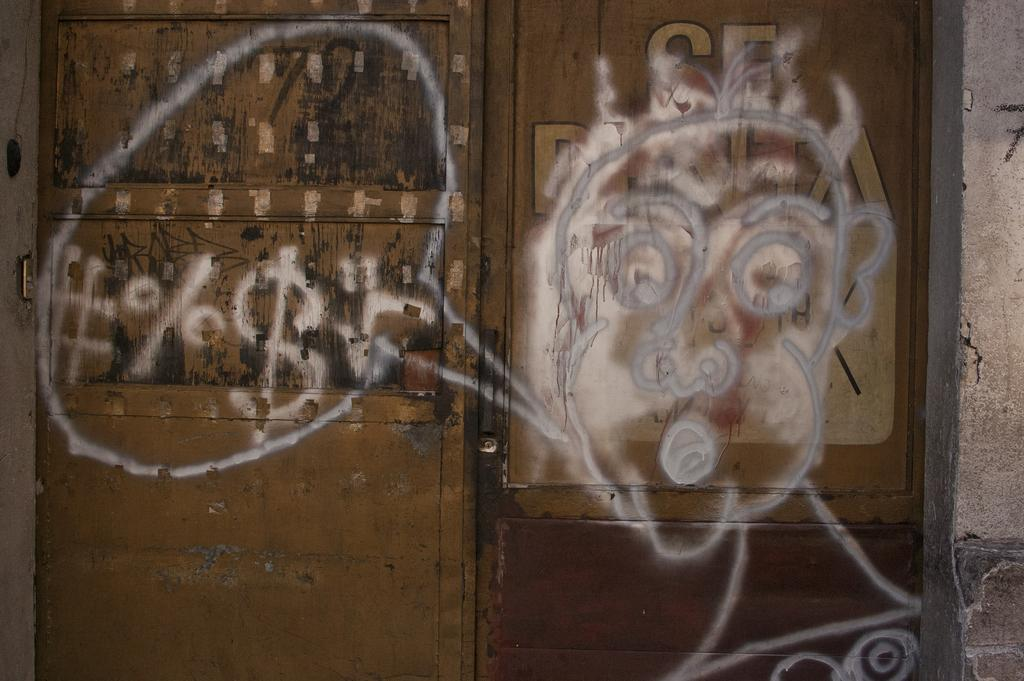What is located in the center of the image? There is a wall in the center of the image. What feature is present on the wall? There is a door in the image. What is on the door? There is a painting and text on the door. What type of silk is draped over the painting on the door? There is no silk present in the image; it only features a painting and text on the door. 